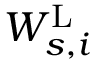<formula> <loc_0><loc_0><loc_500><loc_500>W _ { s , i } ^ { L }</formula> 